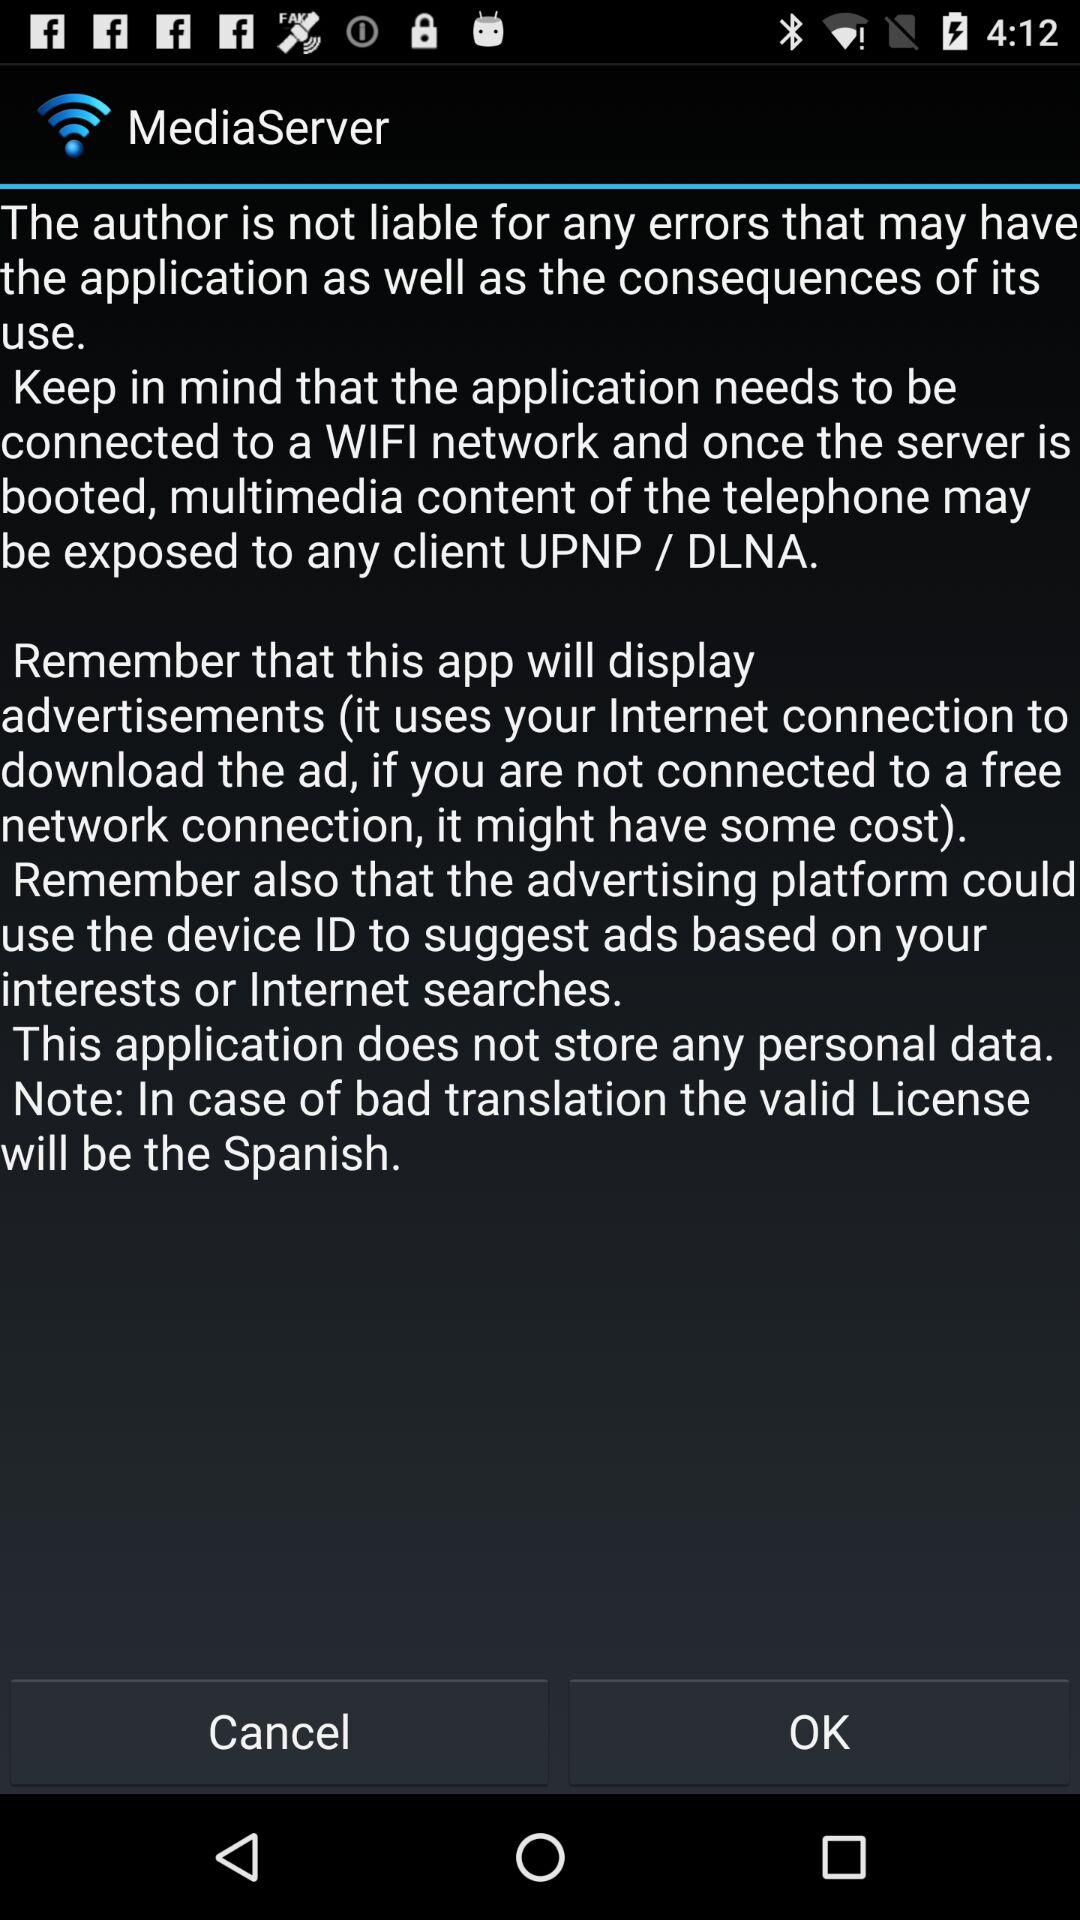What will be the valid license in case of bad translation? The valid license in case of bad translation will be Spanish. 